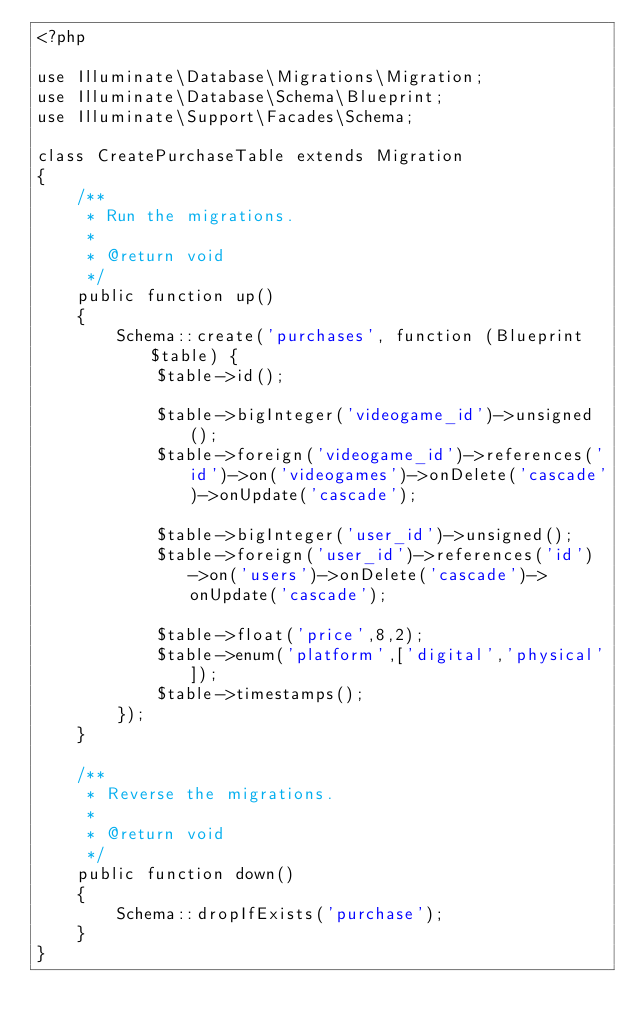<code> <loc_0><loc_0><loc_500><loc_500><_PHP_><?php

use Illuminate\Database\Migrations\Migration;
use Illuminate\Database\Schema\Blueprint;
use Illuminate\Support\Facades\Schema;

class CreatePurchaseTable extends Migration
{
    /**
     * Run the migrations.
     *
     * @return void
     */
    public function up()
    {
        Schema::create('purchases', function (Blueprint $table) {
            $table->id();

            $table->bigInteger('videogame_id')->unsigned();
            $table->foreign('videogame_id')->references('id')->on('videogames')->onDelete('cascade')->onUpdate('cascade');

            $table->bigInteger('user_id')->unsigned();
            $table->foreign('user_id')->references('id')->on('users')->onDelete('cascade')->onUpdate('cascade');

            $table->float('price',8,2);
            $table->enum('platform',['digital','physical']);
            $table->timestamps();
        });
    }

    /**
     * Reverse the migrations.
     *
     * @return void
     */
    public function down()
    {
        Schema::dropIfExists('purchase');
    }
}
</code> 